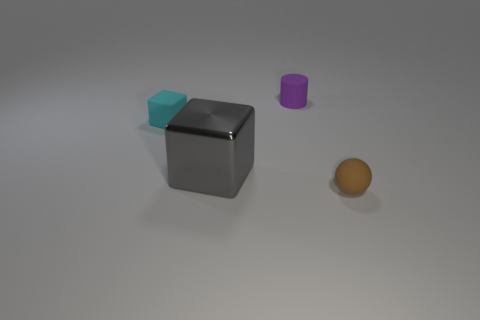Add 3 big brown metallic balls. How many objects exist? 7 Subtract all spheres. How many objects are left? 3 Subtract all small purple cylinders. Subtract all tiny brown balls. How many objects are left? 2 Add 3 matte cylinders. How many matte cylinders are left? 4 Add 3 rubber cubes. How many rubber cubes exist? 4 Subtract 0 red cylinders. How many objects are left? 4 Subtract all green blocks. Subtract all brown balls. How many blocks are left? 2 